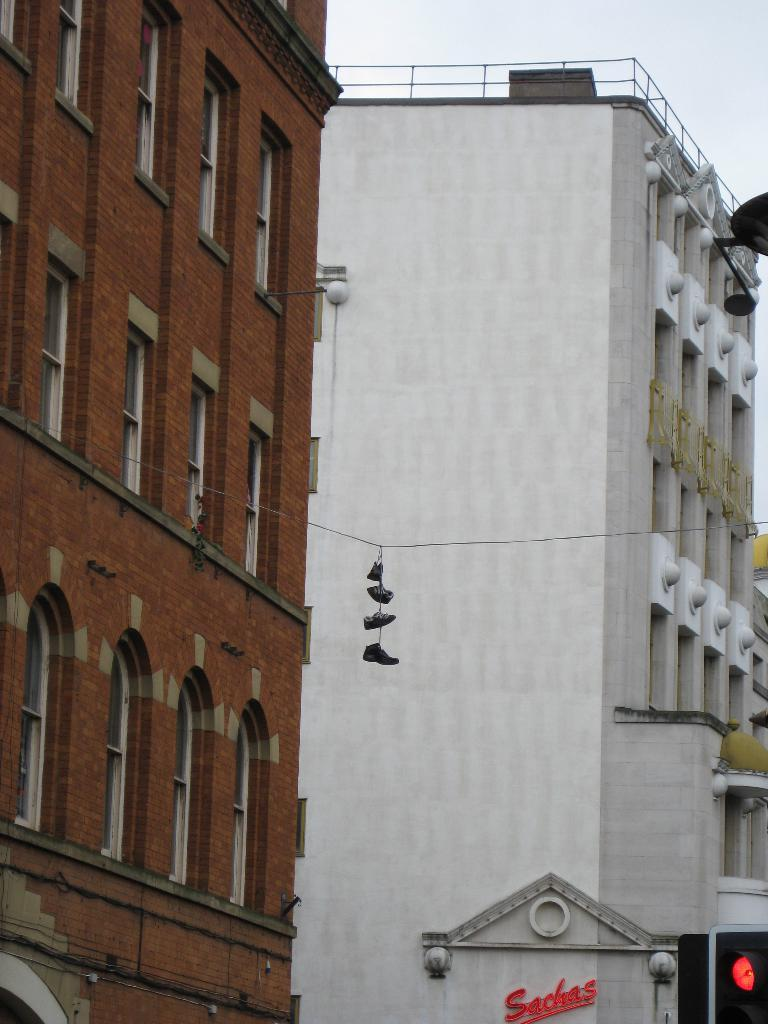What is located in the middle of the image? There are shoes in the middle of the image. What can be seen in the background of the image? There are buildings and metal rods in the background of the image. What type of infrastructure is present at the bottom of the image? There are traffic lights at the bottom of the image. What type of plants can be seen growing from the shoes in the image? There are no plants growing from the shoes in the image. What is the neck size of the person wearing the shoes in the image? There is no person wearing the shoes in the image, so we cannot determine the neck size. 